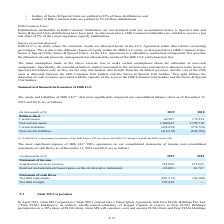From Golar Lng's financial document, In which years was the assets and liabilities recorded for? The document shows two values: 2019 and 2018. From the document: "(in thousands of $) 2019 2018 Balance sheet Current assets 64,507 172,554 (in thousands of $) 2019 2018 Balance sheet Current assets 64,507 172,554..." Also, Who is the primary beneficiary of the Hilli Lessor VIE ? According to the financial document, Hilli LLC. The relevant text states: "Impact of partial disposal: Hilli LLC is an entity where the economic results are allocated based on the LLC Agreement rather than relati Impact of partial disposal: Hilli LLC is an entity where the e..." Also, What was the current liabilities in 2018? According to the financial document, (278,728) (in thousands). The relevant text states: "Current liabilities (496,029) (278,728) Non-current liabilities (418,578) (842,786)..." Additionally, Which year was the non-current liabilities higher? According to the financial document, 2018. The relevant text states: "(in thousands of $) 2019 2018 Balance sheet Current assets 64,507 172,554..." Also, can you calculate: What was the change in current assets between 2018 and 2019? Based on the calculation: 64,507 - 172,554 , the result is -108047 (in thousands). This is based on the information: "$) 2019 2018 Balance sheet Current assets 64,507 172,554 ands of $) 2019 2018 Balance sheet Current assets 64,507 172,554..." The key data points involved are: 172,554, 64,507. Also, can you calculate: What was the percentage change in non-current assets between 2018 and 2019? To answer this question, I need to perform calculations using the financial data. The calculation is: (1,300,065 - 1,392,710)/1,392,710 , which equals -6.65 (percentage). This is based on the information: "Non-current assets 1,300,065 1,392,710 Non-current assets 1,300,065 1,392,710..." The key data points involved are: 1,300,065, 1,392,710. 